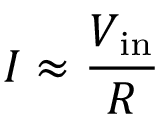Convert formula to latex. <formula><loc_0><loc_0><loc_500><loc_500>I \approx { \frac { V _ { i n } } { R } }</formula> 